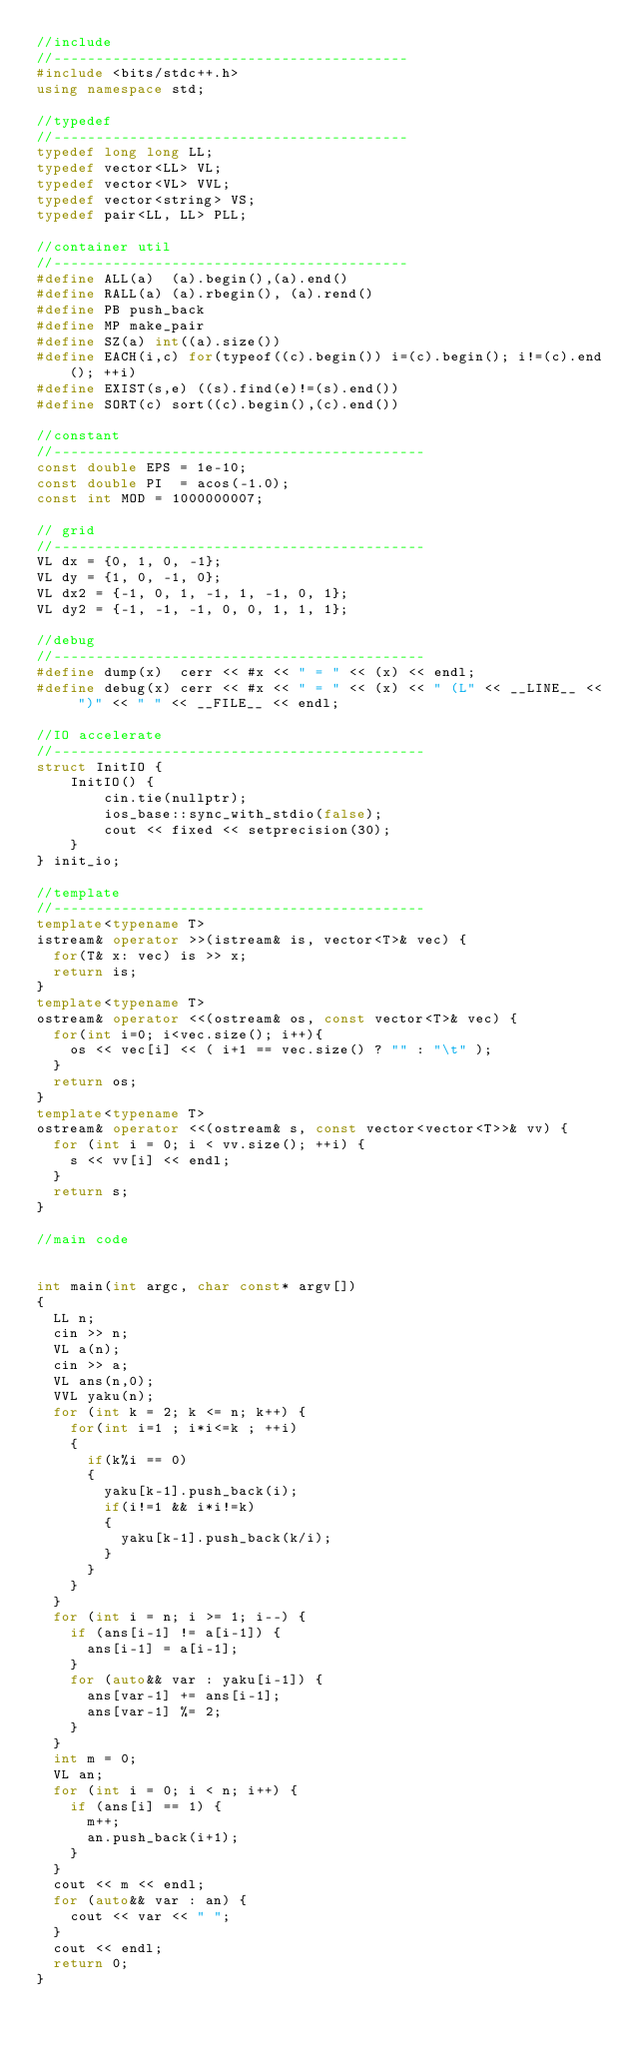<code> <loc_0><loc_0><loc_500><loc_500><_C++_>//include
//------------------------------------------
#include <bits/stdc++.h>
using namespace std;

//typedef
//------------------------------------------
typedef long long LL;
typedef vector<LL> VL;
typedef vector<VL> VVL;
typedef vector<string> VS;
typedef pair<LL, LL> PLL;

//container util
//------------------------------------------
#define ALL(a)  (a).begin(),(a).end()
#define RALL(a) (a).rbegin(), (a).rend()
#define PB push_back
#define MP make_pair
#define SZ(a) int((a).size())
#define EACH(i,c) for(typeof((c).begin()) i=(c).begin(); i!=(c).end(); ++i)
#define EXIST(s,e) ((s).find(e)!=(s).end())
#define SORT(c) sort((c).begin(),(c).end())

//constant
//--------------------------------------------
const double EPS = 1e-10;
const double PI  = acos(-1.0);
const int MOD = 1000000007;

// grid
//--------------------------------------------
VL dx = {0, 1, 0, -1};
VL dy = {1, 0, -1, 0};
VL dx2 = {-1, 0, 1, -1, 1, -1, 0, 1};
VL dy2 = {-1, -1, -1, 0, 0, 1, 1, 1};

//debug
//--------------------------------------------
#define dump(x)  cerr << #x << " = " << (x) << endl;
#define debug(x) cerr << #x << " = " << (x) << " (L" << __LINE__ << ")" << " " << __FILE__ << endl;

//IO accelerate
//--------------------------------------------
struct InitIO {
    InitIO() {
        cin.tie(nullptr);
        ios_base::sync_with_stdio(false);
        cout << fixed << setprecision(30);
    }
} init_io;

//template
//--------------------------------------------
template<typename T>
istream& operator >>(istream& is, vector<T>& vec) {
  for(T& x: vec) is >> x;
  return is;
}
template<typename T>
ostream& operator <<(ostream& os, const vector<T>& vec) {
  for(int i=0; i<vec.size(); i++){
    os << vec[i] << ( i+1 == vec.size() ? "" : "\t" );
  }
  return os;
}
template<typename T>
ostream& operator <<(ostream& s, const vector<vector<T>>& vv) {
	for (int i = 0; i < vv.size(); ++i) {
		s << vv[i] << endl;
	}
	return s;
}

//main code


int main(int argc, char const* argv[])
{
	LL n;
	cin >> n;
	VL a(n);
	cin >> a;
	VL ans(n,0);
	VVL yaku(n);
	for (int k = 2; k <= n; k++) {
		for(int i=1 ; i*i<=k ; ++i)
		{
			if(k%i == 0)
			{
				yaku[k-1].push_back(i);
				if(i!=1 && i*i!=k)
				{
					yaku[k-1].push_back(k/i);
				}
			}
		}
	}
	for (int i = n; i >= 1; i--) {
		if (ans[i-1] != a[i-1]) {
			ans[i-1] = a[i-1];
		}
		for (auto&& var : yaku[i-1]) {
			ans[var-1] += ans[i-1];
			ans[var-1] %= 2;
		}
	}
	int m = 0;
	VL an;
	for (int i = 0; i < n; i++) {
		if (ans[i] == 1) {
			m++;
			an.push_back(i+1);
		}
	}
	cout << m << endl;
	for (auto&& var : an) {
		cout << var << " ";
	}
	cout << endl;
	return 0;
}
</code> 